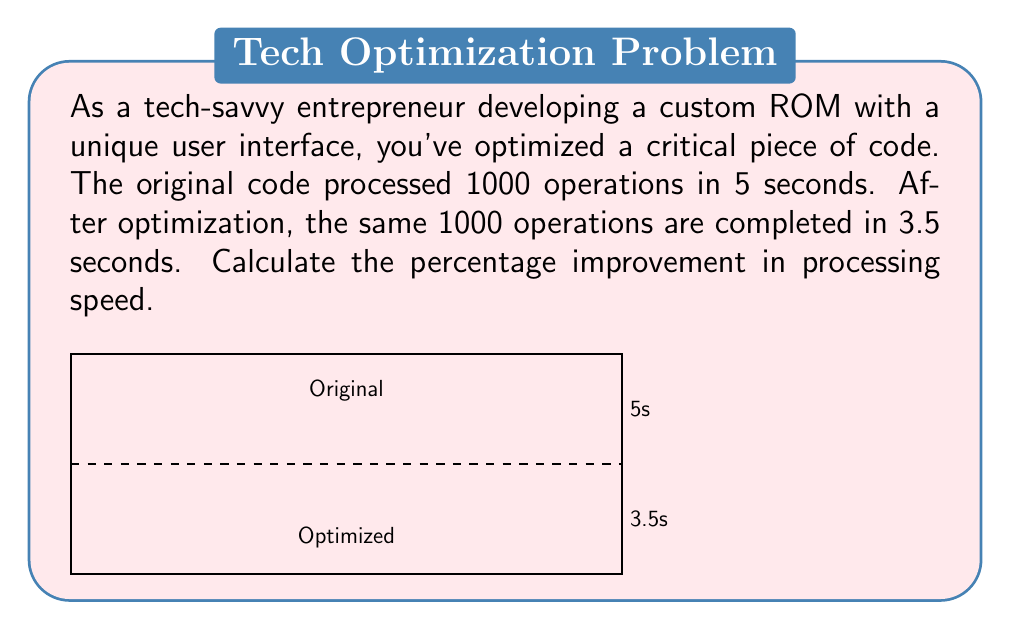Solve this math problem. Let's approach this step-by-step:

1) First, we need to calculate the processing speeds for both the original and optimized code.

   Speed = Number of operations / Time taken

2) For the original code:
   $$\text{Original Speed} = \frac{1000 \text{ operations}}{5 \text{ seconds}} = 200 \text{ operations/second}$$

3) For the optimized code:
   $$\text{Optimized Speed} = \frac{1000 \text{ operations}}{3.5 \text{ seconds}} \approx 285.71 \text{ operations/second}$$

4) To calculate the percentage improvement, we use the formula:
   $$\text{Percentage Improvement} = \frac{\text{Increase in Speed}}{\text{Original Speed}} \times 100\%$$

5) Increase in Speed = Optimized Speed - Original Speed
   $$285.71 - 200 = 85.71 \text{ operations/second}$$

6) Now, let's plug this into our percentage improvement formula:
   $$\text{Percentage Improvement} = \frac{85.71}{200} \times 100\% = 0.4285 \times 100\% = 42.85\%$$

Therefore, the percentage improvement in processing speed is approximately 42.85%.
Answer: 42.85% 